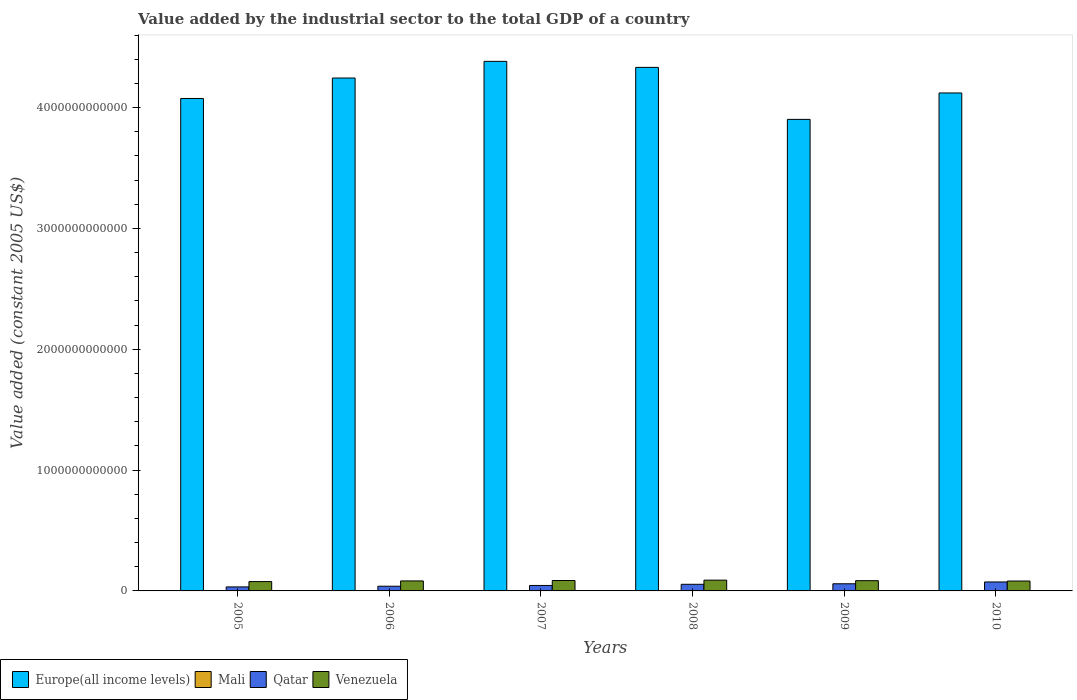How many different coloured bars are there?
Give a very brief answer. 4. How many bars are there on the 2nd tick from the right?
Make the answer very short. 4. What is the label of the 5th group of bars from the left?
Provide a short and direct response. 2009. In how many cases, is the number of bars for a given year not equal to the number of legend labels?
Provide a succinct answer. 0. What is the value added by the industrial sector in Mali in 2007?
Give a very brief answer. 1.26e+09. Across all years, what is the maximum value added by the industrial sector in Mali?
Offer a terse response. 1.32e+09. Across all years, what is the minimum value added by the industrial sector in Venezuela?
Provide a succinct answer. 7.73e+1. In which year was the value added by the industrial sector in Venezuela maximum?
Your response must be concise. 2008. What is the total value added by the industrial sector in Qatar in the graph?
Provide a succinct answer. 3.05e+11. What is the difference between the value added by the industrial sector in Mali in 2005 and that in 2010?
Offer a terse response. 1.24e+06. What is the difference between the value added by the industrial sector in Qatar in 2007 and the value added by the industrial sector in Mali in 2010?
Offer a very short reply. 4.40e+1. What is the average value added by the industrial sector in Mali per year?
Give a very brief answer. 1.24e+09. In the year 2006, what is the difference between the value added by the industrial sector in Europe(all income levels) and value added by the industrial sector in Mali?
Make the answer very short. 4.24e+12. In how many years, is the value added by the industrial sector in Europe(all income levels) greater than 1400000000000 US$?
Give a very brief answer. 6. What is the ratio of the value added by the industrial sector in Europe(all income levels) in 2006 to that in 2010?
Give a very brief answer. 1.03. Is the difference between the value added by the industrial sector in Europe(all income levels) in 2006 and 2009 greater than the difference between the value added by the industrial sector in Mali in 2006 and 2009?
Provide a succinct answer. Yes. What is the difference between the highest and the second highest value added by the industrial sector in Venezuela?
Provide a succinct answer. 3.08e+09. What is the difference between the highest and the lowest value added by the industrial sector in Mali?
Keep it short and to the point. 1.18e+08. In how many years, is the value added by the industrial sector in Mali greater than the average value added by the industrial sector in Mali taken over all years?
Your answer should be compact. 3. Is it the case that in every year, the sum of the value added by the industrial sector in Qatar and value added by the industrial sector in Venezuela is greater than the sum of value added by the industrial sector in Europe(all income levels) and value added by the industrial sector in Mali?
Ensure brevity in your answer.  Yes. What does the 4th bar from the left in 2009 represents?
Offer a very short reply. Venezuela. What does the 2nd bar from the right in 2009 represents?
Your answer should be compact. Qatar. Is it the case that in every year, the sum of the value added by the industrial sector in Europe(all income levels) and value added by the industrial sector in Mali is greater than the value added by the industrial sector in Qatar?
Provide a short and direct response. Yes. How many bars are there?
Keep it short and to the point. 24. What is the difference between two consecutive major ticks on the Y-axis?
Your answer should be very brief. 1.00e+12. Where does the legend appear in the graph?
Ensure brevity in your answer.  Bottom left. How many legend labels are there?
Your response must be concise. 4. How are the legend labels stacked?
Offer a terse response. Horizontal. What is the title of the graph?
Keep it short and to the point. Value added by the industrial sector to the total GDP of a country. Does "Pakistan" appear as one of the legend labels in the graph?
Make the answer very short. No. What is the label or title of the Y-axis?
Offer a terse response. Value added (constant 2005 US$). What is the Value added (constant 2005 US$) of Europe(all income levels) in 2005?
Provide a succinct answer. 4.08e+12. What is the Value added (constant 2005 US$) in Mali in 2005?
Keep it short and to the point. 1.22e+09. What is the Value added (constant 2005 US$) in Qatar in 2005?
Make the answer very short. 3.32e+1. What is the Value added (constant 2005 US$) in Venezuela in 2005?
Provide a succinct answer. 7.73e+1. What is the Value added (constant 2005 US$) of Europe(all income levels) in 2006?
Your response must be concise. 4.24e+12. What is the Value added (constant 2005 US$) in Mali in 2006?
Ensure brevity in your answer.  1.32e+09. What is the Value added (constant 2005 US$) of Qatar in 2006?
Provide a succinct answer. 3.89e+1. What is the Value added (constant 2005 US$) in Venezuela in 2006?
Provide a short and direct response. 8.27e+1. What is the Value added (constant 2005 US$) of Europe(all income levels) in 2007?
Make the answer very short. 4.38e+12. What is the Value added (constant 2005 US$) in Mali in 2007?
Your answer should be compact. 1.26e+09. What is the Value added (constant 2005 US$) in Qatar in 2007?
Offer a very short reply. 4.52e+1. What is the Value added (constant 2005 US$) in Venezuela in 2007?
Your answer should be very brief. 8.61e+1. What is the Value added (constant 2005 US$) in Europe(all income levels) in 2008?
Offer a terse response. 4.33e+12. What is the Value added (constant 2005 US$) of Mali in 2008?
Keep it short and to the point. 1.20e+09. What is the Value added (constant 2005 US$) of Qatar in 2008?
Ensure brevity in your answer.  5.49e+1. What is the Value added (constant 2005 US$) of Venezuela in 2008?
Offer a very short reply. 8.92e+1. What is the Value added (constant 2005 US$) in Europe(all income levels) in 2009?
Provide a short and direct response. 3.90e+12. What is the Value added (constant 2005 US$) of Mali in 2009?
Offer a very short reply. 1.24e+09. What is the Value added (constant 2005 US$) of Qatar in 2009?
Give a very brief answer. 5.91e+1. What is the Value added (constant 2005 US$) of Venezuela in 2009?
Give a very brief answer. 8.47e+1. What is the Value added (constant 2005 US$) in Europe(all income levels) in 2010?
Offer a very short reply. 4.12e+12. What is the Value added (constant 2005 US$) in Mali in 2010?
Provide a short and direct response. 1.22e+09. What is the Value added (constant 2005 US$) of Qatar in 2010?
Keep it short and to the point. 7.42e+1. What is the Value added (constant 2005 US$) in Venezuela in 2010?
Provide a short and direct response. 8.19e+1. Across all years, what is the maximum Value added (constant 2005 US$) in Europe(all income levels)?
Provide a short and direct response. 4.38e+12. Across all years, what is the maximum Value added (constant 2005 US$) of Mali?
Offer a terse response. 1.32e+09. Across all years, what is the maximum Value added (constant 2005 US$) of Qatar?
Keep it short and to the point. 7.42e+1. Across all years, what is the maximum Value added (constant 2005 US$) in Venezuela?
Offer a terse response. 8.92e+1. Across all years, what is the minimum Value added (constant 2005 US$) of Europe(all income levels)?
Keep it short and to the point. 3.90e+12. Across all years, what is the minimum Value added (constant 2005 US$) of Mali?
Your answer should be compact. 1.20e+09. Across all years, what is the minimum Value added (constant 2005 US$) of Qatar?
Your answer should be compact. 3.32e+1. Across all years, what is the minimum Value added (constant 2005 US$) of Venezuela?
Offer a very short reply. 7.73e+1. What is the total Value added (constant 2005 US$) in Europe(all income levels) in the graph?
Your response must be concise. 2.51e+13. What is the total Value added (constant 2005 US$) of Mali in the graph?
Make the answer very short. 7.45e+09. What is the total Value added (constant 2005 US$) in Qatar in the graph?
Provide a succinct answer. 3.05e+11. What is the total Value added (constant 2005 US$) in Venezuela in the graph?
Offer a terse response. 5.02e+11. What is the difference between the Value added (constant 2005 US$) of Europe(all income levels) in 2005 and that in 2006?
Your answer should be compact. -1.69e+11. What is the difference between the Value added (constant 2005 US$) of Mali in 2005 and that in 2006?
Ensure brevity in your answer.  -1.01e+08. What is the difference between the Value added (constant 2005 US$) of Qatar in 2005 and that in 2006?
Your response must be concise. -5.69e+09. What is the difference between the Value added (constant 2005 US$) of Venezuela in 2005 and that in 2006?
Your answer should be very brief. -5.46e+09. What is the difference between the Value added (constant 2005 US$) of Europe(all income levels) in 2005 and that in 2007?
Your response must be concise. -3.07e+11. What is the difference between the Value added (constant 2005 US$) in Mali in 2005 and that in 2007?
Your answer should be very brief. -4.04e+07. What is the difference between the Value added (constant 2005 US$) of Qatar in 2005 and that in 2007?
Your answer should be very brief. -1.20e+1. What is the difference between the Value added (constant 2005 US$) in Venezuela in 2005 and that in 2007?
Ensure brevity in your answer.  -8.88e+09. What is the difference between the Value added (constant 2005 US$) of Europe(all income levels) in 2005 and that in 2008?
Your response must be concise. -2.57e+11. What is the difference between the Value added (constant 2005 US$) in Mali in 2005 and that in 2008?
Give a very brief answer. 1.75e+07. What is the difference between the Value added (constant 2005 US$) in Qatar in 2005 and that in 2008?
Your answer should be compact. -2.17e+1. What is the difference between the Value added (constant 2005 US$) in Venezuela in 2005 and that in 2008?
Keep it short and to the point. -1.20e+1. What is the difference between the Value added (constant 2005 US$) of Europe(all income levels) in 2005 and that in 2009?
Offer a very short reply. 1.73e+11. What is the difference between the Value added (constant 2005 US$) of Mali in 2005 and that in 2009?
Offer a terse response. -2.48e+07. What is the difference between the Value added (constant 2005 US$) in Qatar in 2005 and that in 2009?
Your answer should be very brief. -2.60e+1. What is the difference between the Value added (constant 2005 US$) of Venezuela in 2005 and that in 2009?
Your answer should be compact. -7.47e+09. What is the difference between the Value added (constant 2005 US$) in Europe(all income levels) in 2005 and that in 2010?
Your response must be concise. -4.56e+1. What is the difference between the Value added (constant 2005 US$) in Mali in 2005 and that in 2010?
Your response must be concise. 1.24e+06. What is the difference between the Value added (constant 2005 US$) in Qatar in 2005 and that in 2010?
Your answer should be very brief. -4.10e+1. What is the difference between the Value added (constant 2005 US$) of Venezuela in 2005 and that in 2010?
Provide a succinct answer. -4.68e+09. What is the difference between the Value added (constant 2005 US$) in Europe(all income levels) in 2006 and that in 2007?
Keep it short and to the point. -1.38e+11. What is the difference between the Value added (constant 2005 US$) of Mali in 2006 and that in 2007?
Offer a very short reply. 6.04e+07. What is the difference between the Value added (constant 2005 US$) of Qatar in 2006 and that in 2007?
Ensure brevity in your answer.  -6.35e+09. What is the difference between the Value added (constant 2005 US$) in Venezuela in 2006 and that in 2007?
Keep it short and to the point. -3.42e+09. What is the difference between the Value added (constant 2005 US$) of Europe(all income levels) in 2006 and that in 2008?
Give a very brief answer. -8.80e+1. What is the difference between the Value added (constant 2005 US$) of Mali in 2006 and that in 2008?
Give a very brief answer. 1.18e+08. What is the difference between the Value added (constant 2005 US$) of Qatar in 2006 and that in 2008?
Your answer should be very brief. -1.60e+1. What is the difference between the Value added (constant 2005 US$) of Venezuela in 2006 and that in 2008?
Your answer should be compact. -6.50e+09. What is the difference between the Value added (constant 2005 US$) in Europe(all income levels) in 2006 and that in 2009?
Your response must be concise. 3.42e+11. What is the difference between the Value added (constant 2005 US$) in Mali in 2006 and that in 2009?
Offer a very short reply. 7.60e+07. What is the difference between the Value added (constant 2005 US$) in Qatar in 2006 and that in 2009?
Make the answer very short. -2.03e+1. What is the difference between the Value added (constant 2005 US$) of Venezuela in 2006 and that in 2009?
Keep it short and to the point. -2.01e+09. What is the difference between the Value added (constant 2005 US$) of Europe(all income levels) in 2006 and that in 2010?
Keep it short and to the point. 1.24e+11. What is the difference between the Value added (constant 2005 US$) in Mali in 2006 and that in 2010?
Your answer should be very brief. 1.02e+08. What is the difference between the Value added (constant 2005 US$) in Qatar in 2006 and that in 2010?
Provide a short and direct response. -3.54e+1. What is the difference between the Value added (constant 2005 US$) in Venezuela in 2006 and that in 2010?
Provide a succinct answer. 7.86e+08. What is the difference between the Value added (constant 2005 US$) of Europe(all income levels) in 2007 and that in 2008?
Make the answer very short. 4.99e+1. What is the difference between the Value added (constant 2005 US$) of Mali in 2007 and that in 2008?
Offer a very short reply. 5.79e+07. What is the difference between the Value added (constant 2005 US$) of Qatar in 2007 and that in 2008?
Ensure brevity in your answer.  -9.67e+09. What is the difference between the Value added (constant 2005 US$) of Venezuela in 2007 and that in 2008?
Your answer should be compact. -3.08e+09. What is the difference between the Value added (constant 2005 US$) of Europe(all income levels) in 2007 and that in 2009?
Your answer should be very brief. 4.80e+11. What is the difference between the Value added (constant 2005 US$) in Mali in 2007 and that in 2009?
Make the answer very short. 1.56e+07. What is the difference between the Value added (constant 2005 US$) of Qatar in 2007 and that in 2009?
Offer a terse response. -1.39e+1. What is the difference between the Value added (constant 2005 US$) of Venezuela in 2007 and that in 2009?
Ensure brevity in your answer.  1.41e+09. What is the difference between the Value added (constant 2005 US$) in Europe(all income levels) in 2007 and that in 2010?
Your answer should be compact. 2.62e+11. What is the difference between the Value added (constant 2005 US$) of Mali in 2007 and that in 2010?
Make the answer very short. 4.16e+07. What is the difference between the Value added (constant 2005 US$) in Qatar in 2007 and that in 2010?
Offer a very short reply. -2.90e+1. What is the difference between the Value added (constant 2005 US$) in Venezuela in 2007 and that in 2010?
Offer a terse response. 4.21e+09. What is the difference between the Value added (constant 2005 US$) in Europe(all income levels) in 2008 and that in 2009?
Your answer should be very brief. 4.30e+11. What is the difference between the Value added (constant 2005 US$) of Mali in 2008 and that in 2009?
Ensure brevity in your answer.  -4.22e+07. What is the difference between the Value added (constant 2005 US$) in Qatar in 2008 and that in 2009?
Offer a terse response. -4.26e+09. What is the difference between the Value added (constant 2005 US$) of Venezuela in 2008 and that in 2009?
Make the answer very short. 4.49e+09. What is the difference between the Value added (constant 2005 US$) of Europe(all income levels) in 2008 and that in 2010?
Your response must be concise. 2.12e+11. What is the difference between the Value added (constant 2005 US$) in Mali in 2008 and that in 2010?
Keep it short and to the point. -1.62e+07. What is the difference between the Value added (constant 2005 US$) in Qatar in 2008 and that in 2010?
Offer a very short reply. -1.93e+1. What is the difference between the Value added (constant 2005 US$) in Venezuela in 2008 and that in 2010?
Offer a terse response. 7.29e+09. What is the difference between the Value added (constant 2005 US$) of Europe(all income levels) in 2009 and that in 2010?
Give a very brief answer. -2.19e+11. What is the difference between the Value added (constant 2005 US$) of Mali in 2009 and that in 2010?
Offer a very short reply. 2.60e+07. What is the difference between the Value added (constant 2005 US$) in Qatar in 2009 and that in 2010?
Make the answer very short. -1.51e+1. What is the difference between the Value added (constant 2005 US$) in Venezuela in 2009 and that in 2010?
Provide a short and direct response. 2.79e+09. What is the difference between the Value added (constant 2005 US$) in Europe(all income levels) in 2005 and the Value added (constant 2005 US$) in Mali in 2006?
Ensure brevity in your answer.  4.07e+12. What is the difference between the Value added (constant 2005 US$) of Europe(all income levels) in 2005 and the Value added (constant 2005 US$) of Qatar in 2006?
Make the answer very short. 4.04e+12. What is the difference between the Value added (constant 2005 US$) of Europe(all income levels) in 2005 and the Value added (constant 2005 US$) of Venezuela in 2006?
Ensure brevity in your answer.  3.99e+12. What is the difference between the Value added (constant 2005 US$) in Mali in 2005 and the Value added (constant 2005 US$) in Qatar in 2006?
Make the answer very short. -3.76e+1. What is the difference between the Value added (constant 2005 US$) in Mali in 2005 and the Value added (constant 2005 US$) in Venezuela in 2006?
Offer a terse response. -8.15e+1. What is the difference between the Value added (constant 2005 US$) of Qatar in 2005 and the Value added (constant 2005 US$) of Venezuela in 2006?
Provide a short and direct response. -4.95e+1. What is the difference between the Value added (constant 2005 US$) of Europe(all income levels) in 2005 and the Value added (constant 2005 US$) of Mali in 2007?
Keep it short and to the point. 4.07e+12. What is the difference between the Value added (constant 2005 US$) of Europe(all income levels) in 2005 and the Value added (constant 2005 US$) of Qatar in 2007?
Offer a terse response. 4.03e+12. What is the difference between the Value added (constant 2005 US$) in Europe(all income levels) in 2005 and the Value added (constant 2005 US$) in Venezuela in 2007?
Ensure brevity in your answer.  3.99e+12. What is the difference between the Value added (constant 2005 US$) of Mali in 2005 and the Value added (constant 2005 US$) of Qatar in 2007?
Provide a succinct answer. -4.40e+1. What is the difference between the Value added (constant 2005 US$) of Mali in 2005 and the Value added (constant 2005 US$) of Venezuela in 2007?
Provide a succinct answer. -8.49e+1. What is the difference between the Value added (constant 2005 US$) of Qatar in 2005 and the Value added (constant 2005 US$) of Venezuela in 2007?
Your answer should be very brief. -5.30e+1. What is the difference between the Value added (constant 2005 US$) of Europe(all income levels) in 2005 and the Value added (constant 2005 US$) of Mali in 2008?
Your answer should be compact. 4.07e+12. What is the difference between the Value added (constant 2005 US$) in Europe(all income levels) in 2005 and the Value added (constant 2005 US$) in Qatar in 2008?
Keep it short and to the point. 4.02e+12. What is the difference between the Value added (constant 2005 US$) in Europe(all income levels) in 2005 and the Value added (constant 2005 US$) in Venezuela in 2008?
Ensure brevity in your answer.  3.99e+12. What is the difference between the Value added (constant 2005 US$) of Mali in 2005 and the Value added (constant 2005 US$) of Qatar in 2008?
Provide a succinct answer. -5.37e+1. What is the difference between the Value added (constant 2005 US$) in Mali in 2005 and the Value added (constant 2005 US$) in Venezuela in 2008?
Your response must be concise. -8.80e+1. What is the difference between the Value added (constant 2005 US$) of Qatar in 2005 and the Value added (constant 2005 US$) of Venezuela in 2008?
Provide a short and direct response. -5.60e+1. What is the difference between the Value added (constant 2005 US$) in Europe(all income levels) in 2005 and the Value added (constant 2005 US$) in Mali in 2009?
Make the answer very short. 4.07e+12. What is the difference between the Value added (constant 2005 US$) of Europe(all income levels) in 2005 and the Value added (constant 2005 US$) of Qatar in 2009?
Your answer should be very brief. 4.02e+12. What is the difference between the Value added (constant 2005 US$) of Europe(all income levels) in 2005 and the Value added (constant 2005 US$) of Venezuela in 2009?
Give a very brief answer. 3.99e+12. What is the difference between the Value added (constant 2005 US$) in Mali in 2005 and the Value added (constant 2005 US$) in Qatar in 2009?
Make the answer very short. -5.79e+1. What is the difference between the Value added (constant 2005 US$) in Mali in 2005 and the Value added (constant 2005 US$) in Venezuela in 2009?
Give a very brief answer. -8.35e+1. What is the difference between the Value added (constant 2005 US$) of Qatar in 2005 and the Value added (constant 2005 US$) of Venezuela in 2009?
Provide a short and direct response. -5.15e+1. What is the difference between the Value added (constant 2005 US$) of Europe(all income levels) in 2005 and the Value added (constant 2005 US$) of Mali in 2010?
Offer a terse response. 4.07e+12. What is the difference between the Value added (constant 2005 US$) in Europe(all income levels) in 2005 and the Value added (constant 2005 US$) in Qatar in 2010?
Make the answer very short. 4.00e+12. What is the difference between the Value added (constant 2005 US$) in Europe(all income levels) in 2005 and the Value added (constant 2005 US$) in Venezuela in 2010?
Keep it short and to the point. 3.99e+12. What is the difference between the Value added (constant 2005 US$) in Mali in 2005 and the Value added (constant 2005 US$) in Qatar in 2010?
Offer a very short reply. -7.30e+1. What is the difference between the Value added (constant 2005 US$) in Mali in 2005 and the Value added (constant 2005 US$) in Venezuela in 2010?
Ensure brevity in your answer.  -8.07e+1. What is the difference between the Value added (constant 2005 US$) in Qatar in 2005 and the Value added (constant 2005 US$) in Venezuela in 2010?
Your answer should be very brief. -4.88e+1. What is the difference between the Value added (constant 2005 US$) in Europe(all income levels) in 2006 and the Value added (constant 2005 US$) in Mali in 2007?
Ensure brevity in your answer.  4.24e+12. What is the difference between the Value added (constant 2005 US$) in Europe(all income levels) in 2006 and the Value added (constant 2005 US$) in Qatar in 2007?
Ensure brevity in your answer.  4.20e+12. What is the difference between the Value added (constant 2005 US$) in Europe(all income levels) in 2006 and the Value added (constant 2005 US$) in Venezuela in 2007?
Your response must be concise. 4.16e+12. What is the difference between the Value added (constant 2005 US$) of Mali in 2006 and the Value added (constant 2005 US$) of Qatar in 2007?
Give a very brief answer. -4.39e+1. What is the difference between the Value added (constant 2005 US$) of Mali in 2006 and the Value added (constant 2005 US$) of Venezuela in 2007?
Your answer should be very brief. -8.48e+1. What is the difference between the Value added (constant 2005 US$) in Qatar in 2006 and the Value added (constant 2005 US$) in Venezuela in 2007?
Ensure brevity in your answer.  -4.73e+1. What is the difference between the Value added (constant 2005 US$) in Europe(all income levels) in 2006 and the Value added (constant 2005 US$) in Mali in 2008?
Give a very brief answer. 4.24e+12. What is the difference between the Value added (constant 2005 US$) in Europe(all income levels) in 2006 and the Value added (constant 2005 US$) in Qatar in 2008?
Your answer should be compact. 4.19e+12. What is the difference between the Value added (constant 2005 US$) in Europe(all income levels) in 2006 and the Value added (constant 2005 US$) in Venezuela in 2008?
Ensure brevity in your answer.  4.16e+12. What is the difference between the Value added (constant 2005 US$) in Mali in 2006 and the Value added (constant 2005 US$) in Qatar in 2008?
Your response must be concise. -5.36e+1. What is the difference between the Value added (constant 2005 US$) of Mali in 2006 and the Value added (constant 2005 US$) of Venezuela in 2008?
Offer a very short reply. -8.79e+1. What is the difference between the Value added (constant 2005 US$) of Qatar in 2006 and the Value added (constant 2005 US$) of Venezuela in 2008?
Ensure brevity in your answer.  -5.04e+1. What is the difference between the Value added (constant 2005 US$) in Europe(all income levels) in 2006 and the Value added (constant 2005 US$) in Mali in 2009?
Keep it short and to the point. 4.24e+12. What is the difference between the Value added (constant 2005 US$) of Europe(all income levels) in 2006 and the Value added (constant 2005 US$) of Qatar in 2009?
Give a very brief answer. 4.19e+12. What is the difference between the Value added (constant 2005 US$) of Europe(all income levels) in 2006 and the Value added (constant 2005 US$) of Venezuela in 2009?
Provide a short and direct response. 4.16e+12. What is the difference between the Value added (constant 2005 US$) of Mali in 2006 and the Value added (constant 2005 US$) of Qatar in 2009?
Ensure brevity in your answer.  -5.78e+1. What is the difference between the Value added (constant 2005 US$) of Mali in 2006 and the Value added (constant 2005 US$) of Venezuela in 2009?
Ensure brevity in your answer.  -8.34e+1. What is the difference between the Value added (constant 2005 US$) of Qatar in 2006 and the Value added (constant 2005 US$) of Venezuela in 2009?
Offer a very short reply. -4.59e+1. What is the difference between the Value added (constant 2005 US$) of Europe(all income levels) in 2006 and the Value added (constant 2005 US$) of Mali in 2010?
Provide a short and direct response. 4.24e+12. What is the difference between the Value added (constant 2005 US$) of Europe(all income levels) in 2006 and the Value added (constant 2005 US$) of Qatar in 2010?
Offer a very short reply. 4.17e+12. What is the difference between the Value added (constant 2005 US$) in Europe(all income levels) in 2006 and the Value added (constant 2005 US$) in Venezuela in 2010?
Your answer should be very brief. 4.16e+12. What is the difference between the Value added (constant 2005 US$) in Mali in 2006 and the Value added (constant 2005 US$) in Qatar in 2010?
Give a very brief answer. -7.29e+1. What is the difference between the Value added (constant 2005 US$) in Mali in 2006 and the Value added (constant 2005 US$) in Venezuela in 2010?
Your response must be concise. -8.06e+1. What is the difference between the Value added (constant 2005 US$) in Qatar in 2006 and the Value added (constant 2005 US$) in Venezuela in 2010?
Offer a very short reply. -4.31e+1. What is the difference between the Value added (constant 2005 US$) in Europe(all income levels) in 2007 and the Value added (constant 2005 US$) in Mali in 2008?
Your answer should be very brief. 4.38e+12. What is the difference between the Value added (constant 2005 US$) in Europe(all income levels) in 2007 and the Value added (constant 2005 US$) in Qatar in 2008?
Offer a terse response. 4.33e+12. What is the difference between the Value added (constant 2005 US$) in Europe(all income levels) in 2007 and the Value added (constant 2005 US$) in Venezuela in 2008?
Your response must be concise. 4.29e+12. What is the difference between the Value added (constant 2005 US$) of Mali in 2007 and the Value added (constant 2005 US$) of Qatar in 2008?
Your answer should be compact. -5.36e+1. What is the difference between the Value added (constant 2005 US$) in Mali in 2007 and the Value added (constant 2005 US$) in Venezuela in 2008?
Your answer should be compact. -8.80e+1. What is the difference between the Value added (constant 2005 US$) in Qatar in 2007 and the Value added (constant 2005 US$) in Venezuela in 2008?
Provide a short and direct response. -4.40e+1. What is the difference between the Value added (constant 2005 US$) of Europe(all income levels) in 2007 and the Value added (constant 2005 US$) of Mali in 2009?
Your answer should be compact. 4.38e+12. What is the difference between the Value added (constant 2005 US$) of Europe(all income levels) in 2007 and the Value added (constant 2005 US$) of Qatar in 2009?
Ensure brevity in your answer.  4.32e+12. What is the difference between the Value added (constant 2005 US$) in Europe(all income levels) in 2007 and the Value added (constant 2005 US$) in Venezuela in 2009?
Provide a succinct answer. 4.30e+12. What is the difference between the Value added (constant 2005 US$) in Mali in 2007 and the Value added (constant 2005 US$) in Qatar in 2009?
Offer a terse response. -5.79e+1. What is the difference between the Value added (constant 2005 US$) in Mali in 2007 and the Value added (constant 2005 US$) in Venezuela in 2009?
Your response must be concise. -8.35e+1. What is the difference between the Value added (constant 2005 US$) in Qatar in 2007 and the Value added (constant 2005 US$) in Venezuela in 2009?
Make the answer very short. -3.95e+1. What is the difference between the Value added (constant 2005 US$) in Europe(all income levels) in 2007 and the Value added (constant 2005 US$) in Mali in 2010?
Your answer should be very brief. 4.38e+12. What is the difference between the Value added (constant 2005 US$) in Europe(all income levels) in 2007 and the Value added (constant 2005 US$) in Qatar in 2010?
Offer a terse response. 4.31e+12. What is the difference between the Value added (constant 2005 US$) in Europe(all income levels) in 2007 and the Value added (constant 2005 US$) in Venezuela in 2010?
Make the answer very short. 4.30e+12. What is the difference between the Value added (constant 2005 US$) in Mali in 2007 and the Value added (constant 2005 US$) in Qatar in 2010?
Make the answer very short. -7.30e+1. What is the difference between the Value added (constant 2005 US$) in Mali in 2007 and the Value added (constant 2005 US$) in Venezuela in 2010?
Your answer should be compact. -8.07e+1. What is the difference between the Value added (constant 2005 US$) in Qatar in 2007 and the Value added (constant 2005 US$) in Venezuela in 2010?
Give a very brief answer. -3.67e+1. What is the difference between the Value added (constant 2005 US$) of Europe(all income levels) in 2008 and the Value added (constant 2005 US$) of Mali in 2009?
Offer a terse response. 4.33e+12. What is the difference between the Value added (constant 2005 US$) in Europe(all income levels) in 2008 and the Value added (constant 2005 US$) in Qatar in 2009?
Make the answer very short. 4.27e+12. What is the difference between the Value added (constant 2005 US$) of Europe(all income levels) in 2008 and the Value added (constant 2005 US$) of Venezuela in 2009?
Make the answer very short. 4.25e+12. What is the difference between the Value added (constant 2005 US$) of Mali in 2008 and the Value added (constant 2005 US$) of Qatar in 2009?
Your response must be concise. -5.79e+1. What is the difference between the Value added (constant 2005 US$) in Mali in 2008 and the Value added (constant 2005 US$) in Venezuela in 2009?
Offer a very short reply. -8.35e+1. What is the difference between the Value added (constant 2005 US$) of Qatar in 2008 and the Value added (constant 2005 US$) of Venezuela in 2009?
Provide a succinct answer. -2.98e+1. What is the difference between the Value added (constant 2005 US$) in Europe(all income levels) in 2008 and the Value added (constant 2005 US$) in Mali in 2010?
Offer a terse response. 4.33e+12. What is the difference between the Value added (constant 2005 US$) in Europe(all income levels) in 2008 and the Value added (constant 2005 US$) in Qatar in 2010?
Give a very brief answer. 4.26e+12. What is the difference between the Value added (constant 2005 US$) of Europe(all income levels) in 2008 and the Value added (constant 2005 US$) of Venezuela in 2010?
Offer a terse response. 4.25e+12. What is the difference between the Value added (constant 2005 US$) of Mali in 2008 and the Value added (constant 2005 US$) of Qatar in 2010?
Provide a succinct answer. -7.30e+1. What is the difference between the Value added (constant 2005 US$) of Mali in 2008 and the Value added (constant 2005 US$) of Venezuela in 2010?
Give a very brief answer. -8.07e+1. What is the difference between the Value added (constant 2005 US$) in Qatar in 2008 and the Value added (constant 2005 US$) in Venezuela in 2010?
Your answer should be very brief. -2.70e+1. What is the difference between the Value added (constant 2005 US$) of Europe(all income levels) in 2009 and the Value added (constant 2005 US$) of Mali in 2010?
Make the answer very short. 3.90e+12. What is the difference between the Value added (constant 2005 US$) of Europe(all income levels) in 2009 and the Value added (constant 2005 US$) of Qatar in 2010?
Your answer should be very brief. 3.83e+12. What is the difference between the Value added (constant 2005 US$) of Europe(all income levels) in 2009 and the Value added (constant 2005 US$) of Venezuela in 2010?
Your answer should be compact. 3.82e+12. What is the difference between the Value added (constant 2005 US$) of Mali in 2009 and the Value added (constant 2005 US$) of Qatar in 2010?
Ensure brevity in your answer.  -7.30e+1. What is the difference between the Value added (constant 2005 US$) in Mali in 2009 and the Value added (constant 2005 US$) in Venezuela in 2010?
Your response must be concise. -8.07e+1. What is the difference between the Value added (constant 2005 US$) of Qatar in 2009 and the Value added (constant 2005 US$) of Venezuela in 2010?
Your answer should be compact. -2.28e+1. What is the average Value added (constant 2005 US$) in Europe(all income levels) per year?
Your answer should be compact. 4.18e+12. What is the average Value added (constant 2005 US$) in Mali per year?
Make the answer very short. 1.24e+09. What is the average Value added (constant 2005 US$) of Qatar per year?
Make the answer very short. 5.09e+1. What is the average Value added (constant 2005 US$) in Venezuela per year?
Your answer should be compact. 8.37e+1. In the year 2005, what is the difference between the Value added (constant 2005 US$) in Europe(all income levels) and Value added (constant 2005 US$) in Mali?
Your answer should be compact. 4.07e+12. In the year 2005, what is the difference between the Value added (constant 2005 US$) of Europe(all income levels) and Value added (constant 2005 US$) of Qatar?
Provide a short and direct response. 4.04e+12. In the year 2005, what is the difference between the Value added (constant 2005 US$) of Europe(all income levels) and Value added (constant 2005 US$) of Venezuela?
Your answer should be compact. 4.00e+12. In the year 2005, what is the difference between the Value added (constant 2005 US$) in Mali and Value added (constant 2005 US$) in Qatar?
Offer a very short reply. -3.20e+1. In the year 2005, what is the difference between the Value added (constant 2005 US$) of Mali and Value added (constant 2005 US$) of Venezuela?
Give a very brief answer. -7.60e+1. In the year 2005, what is the difference between the Value added (constant 2005 US$) in Qatar and Value added (constant 2005 US$) in Venezuela?
Your answer should be very brief. -4.41e+1. In the year 2006, what is the difference between the Value added (constant 2005 US$) of Europe(all income levels) and Value added (constant 2005 US$) of Mali?
Make the answer very short. 4.24e+12. In the year 2006, what is the difference between the Value added (constant 2005 US$) in Europe(all income levels) and Value added (constant 2005 US$) in Qatar?
Offer a terse response. 4.21e+12. In the year 2006, what is the difference between the Value added (constant 2005 US$) in Europe(all income levels) and Value added (constant 2005 US$) in Venezuela?
Keep it short and to the point. 4.16e+12. In the year 2006, what is the difference between the Value added (constant 2005 US$) in Mali and Value added (constant 2005 US$) in Qatar?
Provide a succinct answer. -3.75e+1. In the year 2006, what is the difference between the Value added (constant 2005 US$) in Mali and Value added (constant 2005 US$) in Venezuela?
Offer a very short reply. -8.14e+1. In the year 2006, what is the difference between the Value added (constant 2005 US$) of Qatar and Value added (constant 2005 US$) of Venezuela?
Provide a short and direct response. -4.39e+1. In the year 2007, what is the difference between the Value added (constant 2005 US$) of Europe(all income levels) and Value added (constant 2005 US$) of Mali?
Keep it short and to the point. 4.38e+12. In the year 2007, what is the difference between the Value added (constant 2005 US$) in Europe(all income levels) and Value added (constant 2005 US$) in Qatar?
Keep it short and to the point. 4.34e+12. In the year 2007, what is the difference between the Value added (constant 2005 US$) in Europe(all income levels) and Value added (constant 2005 US$) in Venezuela?
Your response must be concise. 4.30e+12. In the year 2007, what is the difference between the Value added (constant 2005 US$) of Mali and Value added (constant 2005 US$) of Qatar?
Your response must be concise. -4.40e+1. In the year 2007, what is the difference between the Value added (constant 2005 US$) in Mali and Value added (constant 2005 US$) in Venezuela?
Keep it short and to the point. -8.49e+1. In the year 2007, what is the difference between the Value added (constant 2005 US$) in Qatar and Value added (constant 2005 US$) in Venezuela?
Keep it short and to the point. -4.09e+1. In the year 2008, what is the difference between the Value added (constant 2005 US$) in Europe(all income levels) and Value added (constant 2005 US$) in Mali?
Ensure brevity in your answer.  4.33e+12. In the year 2008, what is the difference between the Value added (constant 2005 US$) in Europe(all income levels) and Value added (constant 2005 US$) in Qatar?
Offer a very short reply. 4.28e+12. In the year 2008, what is the difference between the Value added (constant 2005 US$) in Europe(all income levels) and Value added (constant 2005 US$) in Venezuela?
Your response must be concise. 4.24e+12. In the year 2008, what is the difference between the Value added (constant 2005 US$) in Mali and Value added (constant 2005 US$) in Qatar?
Offer a very short reply. -5.37e+1. In the year 2008, what is the difference between the Value added (constant 2005 US$) in Mali and Value added (constant 2005 US$) in Venezuela?
Ensure brevity in your answer.  -8.80e+1. In the year 2008, what is the difference between the Value added (constant 2005 US$) of Qatar and Value added (constant 2005 US$) of Venezuela?
Offer a terse response. -3.43e+1. In the year 2009, what is the difference between the Value added (constant 2005 US$) of Europe(all income levels) and Value added (constant 2005 US$) of Mali?
Provide a succinct answer. 3.90e+12. In the year 2009, what is the difference between the Value added (constant 2005 US$) of Europe(all income levels) and Value added (constant 2005 US$) of Qatar?
Your response must be concise. 3.84e+12. In the year 2009, what is the difference between the Value added (constant 2005 US$) in Europe(all income levels) and Value added (constant 2005 US$) in Venezuela?
Your answer should be compact. 3.82e+12. In the year 2009, what is the difference between the Value added (constant 2005 US$) in Mali and Value added (constant 2005 US$) in Qatar?
Keep it short and to the point. -5.79e+1. In the year 2009, what is the difference between the Value added (constant 2005 US$) of Mali and Value added (constant 2005 US$) of Venezuela?
Give a very brief answer. -8.35e+1. In the year 2009, what is the difference between the Value added (constant 2005 US$) of Qatar and Value added (constant 2005 US$) of Venezuela?
Keep it short and to the point. -2.56e+1. In the year 2010, what is the difference between the Value added (constant 2005 US$) in Europe(all income levels) and Value added (constant 2005 US$) in Mali?
Keep it short and to the point. 4.12e+12. In the year 2010, what is the difference between the Value added (constant 2005 US$) in Europe(all income levels) and Value added (constant 2005 US$) in Qatar?
Give a very brief answer. 4.05e+12. In the year 2010, what is the difference between the Value added (constant 2005 US$) of Europe(all income levels) and Value added (constant 2005 US$) of Venezuela?
Your answer should be compact. 4.04e+12. In the year 2010, what is the difference between the Value added (constant 2005 US$) in Mali and Value added (constant 2005 US$) in Qatar?
Make the answer very short. -7.30e+1. In the year 2010, what is the difference between the Value added (constant 2005 US$) of Mali and Value added (constant 2005 US$) of Venezuela?
Offer a very short reply. -8.07e+1. In the year 2010, what is the difference between the Value added (constant 2005 US$) of Qatar and Value added (constant 2005 US$) of Venezuela?
Ensure brevity in your answer.  -7.71e+09. What is the ratio of the Value added (constant 2005 US$) of Europe(all income levels) in 2005 to that in 2006?
Provide a succinct answer. 0.96. What is the ratio of the Value added (constant 2005 US$) of Mali in 2005 to that in 2006?
Provide a short and direct response. 0.92. What is the ratio of the Value added (constant 2005 US$) of Qatar in 2005 to that in 2006?
Keep it short and to the point. 0.85. What is the ratio of the Value added (constant 2005 US$) of Venezuela in 2005 to that in 2006?
Your response must be concise. 0.93. What is the ratio of the Value added (constant 2005 US$) of Europe(all income levels) in 2005 to that in 2007?
Keep it short and to the point. 0.93. What is the ratio of the Value added (constant 2005 US$) of Mali in 2005 to that in 2007?
Your response must be concise. 0.97. What is the ratio of the Value added (constant 2005 US$) in Qatar in 2005 to that in 2007?
Provide a short and direct response. 0.73. What is the ratio of the Value added (constant 2005 US$) in Venezuela in 2005 to that in 2007?
Your answer should be very brief. 0.9. What is the ratio of the Value added (constant 2005 US$) of Europe(all income levels) in 2005 to that in 2008?
Make the answer very short. 0.94. What is the ratio of the Value added (constant 2005 US$) in Mali in 2005 to that in 2008?
Give a very brief answer. 1.01. What is the ratio of the Value added (constant 2005 US$) of Qatar in 2005 to that in 2008?
Offer a terse response. 0.6. What is the ratio of the Value added (constant 2005 US$) of Venezuela in 2005 to that in 2008?
Offer a very short reply. 0.87. What is the ratio of the Value added (constant 2005 US$) of Europe(all income levels) in 2005 to that in 2009?
Your response must be concise. 1.04. What is the ratio of the Value added (constant 2005 US$) of Qatar in 2005 to that in 2009?
Your response must be concise. 0.56. What is the ratio of the Value added (constant 2005 US$) of Venezuela in 2005 to that in 2009?
Ensure brevity in your answer.  0.91. What is the ratio of the Value added (constant 2005 US$) of Europe(all income levels) in 2005 to that in 2010?
Make the answer very short. 0.99. What is the ratio of the Value added (constant 2005 US$) in Mali in 2005 to that in 2010?
Make the answer very short. 1. What is the ratio of the Value added (constant 2005 US$) of Qatar in 2005 to that in 2010?
Provide a short and direct response. 0.45. What is the ratio of the Value added (constant 2005 US$) in Venezuela in 2005 to that in 2010?
Your answer should be compact. 0.94. What is the ratio of the Value added (constant 2005 US$) in Europe(all income levels) in 2006 to that in 2007?
Provide a short and direct response. 0.97. What is the ratio of the Value added (constant 2005 US$) in Mali in 2006 to that in 2007?
Keep it short and to the point. 1.05. What is the ratio of the Value added (constant 2005 US$) of Qatar in 2006 to that in 2007?
Keep it short and to the point. 0.86. What is the ratio of the Value added (constant 2005 US$) in Venezuela in 2006 to that in 2007?
Your answer should be compact. 0.96. What is the ratio of the Value added (constant 2005 US$) of Europe(all income levels) in 2006 to that in 2008?
Your response must be concise. 0.98. What is the ratio of the Value added (constant 2005 US$) in Mali in 2006 to that in 2008?
Ensure brevity in your answer.  1.1. What is the ratio of the Value added (constant 2005 US$) of Qatar in 2006 to that in 2008?
Give a very brief answer. 0.71. What is the ratio of the Value added (constant 2005 US$) of Venezuela in 2006 to that in 2008?
Your response must be concise. 0.93. What is the ratio of the Value added (constant 2005 US$) in Europe(all income levels) in 2006 to that in 2009?
Give a very brief answer. 1.09. What is the ratio of the Value added (constant 2005 US$) of Mali in 2006 to that in 2009?
Give a very brief answer. 1.06. What is the ratio of the Value added (constant 2005 US$) in Qatar in 2006 to that in 2009?
Your answer should be very brief. 0.66. What is the ratio of the Value added (constant 2005 US$) in Venezuela in 2006 to that in 2009?
Give a very brief answer. 0.98. What is the ratio of the Value added (constant 2005 US$) in Mali in 2006 to that in 2010?
Offer a terse response. 1.08. What is the ratio of the Value added (constant 2005 US$) of Qatar in 2006 to that in 2010?
Offer a very short reply. 0.52. What is the ratio of the Value added (constant 2005 US$) of Venezuela in 2006 to that in 2010?
Offer a very short reply. 1.01. What is the ratio of the Value added (constant 2005 US$) in Europe(all income levels) in 2007 to that in 2008?
Your answer should be very brief. 1.01. What is the ratio of the Value added (constant 2005 US$) of Mali in 2007 to that in 2008?
Ensure brevity in your answer.  1.05. What is the ratio of the Value added (constant 2005 US$) of Qatar in 2007 to that in 2008?
Your answer should be very brief. 0.82. What is the ratio of the Value added (constant 2005 US$) in Venezuela in 2007 to that in 2008?
Offer a terse response. 0.97. What is the ratio of the Value added (constant 2005 US$) of Europe(all income levels) in 2007 to that in 2009?
Offer a terse response. 1.12. What is the ratio of the Value added (constant 2005 US$) of Mali in 2007 to that in 2009?
Your answer should be very brief. 1.01. What is the ratio of the Value added (constant 2005 US$) in Qatar in 2007 to that in 2009?
Provide a succinct answer. 0.76. What is the ratio of the Value added (constant 2005 US$) of Venezuela in 2007 to that in 2009?
Provide a short and direct response. 1.02. What is the ratio of the Value added (constant 2005 US$) of Europe(all income levels) in 2007 to that in 2010?
Your answer should be compact. 1.06. What is the ratio of the Value added (constant 2005 US$) in Mali in 2007 to that in 2010?
Your answer should be very brief. 1.03. What is the ratio of the Value added (constant 2005 US$) of Qatar in 2007 to that in 2010?
Give a very brief answer. 0.61. What is the ratio of the Value added (constant 2005 US$) of Venezuela in 2007 to that in 2010?
Offer a terse response. 1.05. What is the ratio of the Value added (constant 2005 US$) of Europe(all income levels) in 2008 to that in 2009?
Ensure brevity in your answer.  1.11. What is the ratio of the Value added (constant 2005 US$) in Mali in 2008 to that in 2009?
Give a very brief answer. 0.97. What is the ratio of the Value added (constant 2005 US$) in Qatar in 2008 to that in 2009?
Offer a terse response. 0.93. What is the ratio of the Value added (constant 2005 US$) in Venezuela in 2008 to that in 2009?
Give a very brief answer. 1.05. What is the ratio of the Value added (constant 2005 US$) in Europe(all income levels) in 2008 to that in 2010?
Give a very brief answer. 1.05. What is the ratio of the Value added (constant 2005 US$) of Mali in 2008 to that in 2010?
Your response must be concise. 0.99. What is the ratio of the Value added (constant 2005 US$) in Qatar in 2008 to that in 2010?
Offer a terse response. 0.74. What is the ratio of the Value added (constant 2005 US$) of Venezuela in 2008 to that in 2010?
Your answer should be compact. 1.09. What is the ratio of the Value added (constant 2005 US$) in Europe(all income levels) in 2009 to that in 2010?
Make the answer very short. 0.95. What is the ratio of the Value added (constant 2005 US$) of Mali in 2009 to that in 2010?
Make the answer very short. 1.02. What is the ratio of the Value added (constant 2005 US$) of Qatar in 2009 to that in 2010?
Ensure brevity in your answer.  0.8. What is the ratio of the Value added (constant 2005 US$) of Venezuela in 2009 to that in 2010?
Give a very brief answer. 1.03. What is the difference between the highest and the second highest Value added (constant 2005 US$) of Europe(all income levels)?
Offer a terse response. 4.99e+1. What is the difference between the highest and the second highest Value added (constant 2005 US$) in Mali?
Keep it short and to the point. 6.04e+07. What is the difference between the highest and the second highest Value added (constant 2005 US$) in Qatar?
Your response must be concise. 1.51e+1. What is the difference between the highest and the second highest Value added (constant 2005 US$) of Venezuela?
Provide a short and direct response. 3.08e+09. What is the difference between the highest and the lowest Value added (constant 2005 US$) of Europe(all income levels)?
Your answer should be compact. 4.80e+11. What is the difference between the highest and the lowest Value added (constant 2005 US$) in Mali?
Offer a very short reply. 1.18e+08. What is the difference between the highest and the lowest Value added (constant 2005 US$) in Qatar?
Your answer should be compact. 4.10e+1. What is the difference between the highest and the lowest Value added (constant 2005 US$) in Venezuela?
Give a very brief answer. 1.20e+1. 